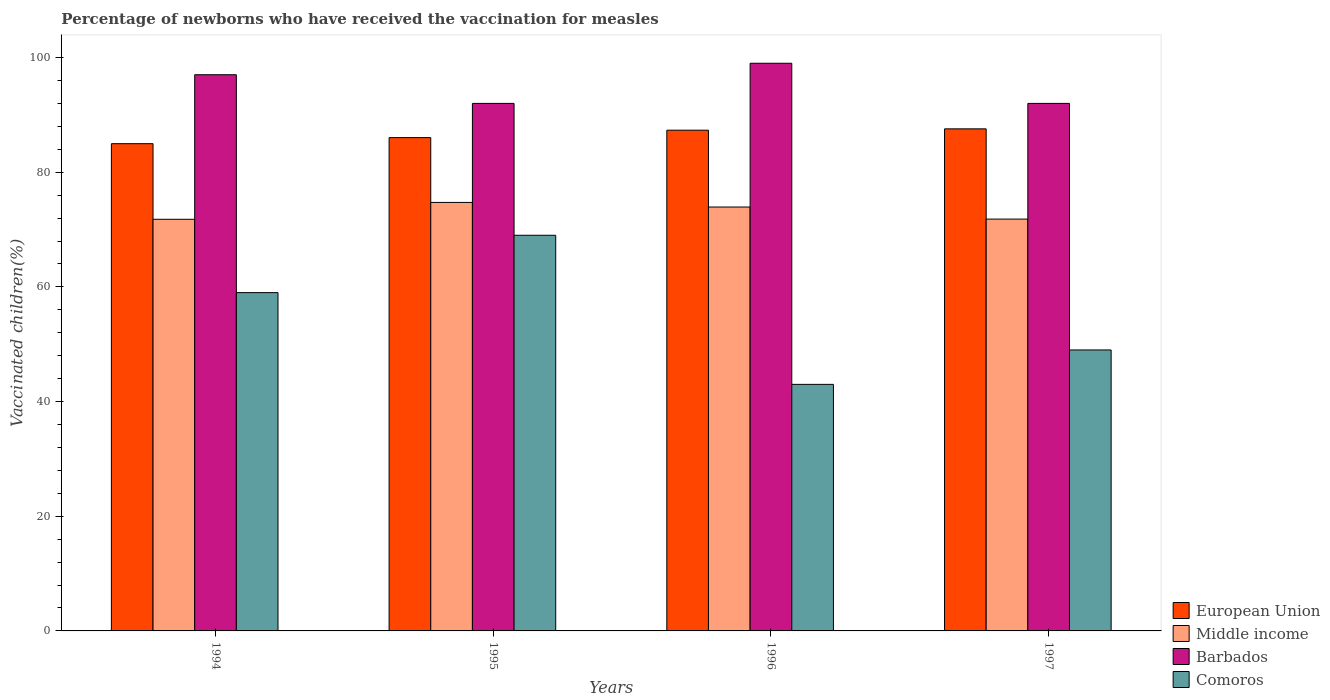How many different coloured bars are there?
Make the answer very short. 4. How many bars are there on the 1st tick from the right?
Ensure brevity in your answer.  4. What is the label of the 1st group of bars from the left?
Provide a short and direct response. 1994. In how many cases, is the number of bars for a given year not equal to the number of legend labels?
Keep it short and to the point. 0. What is the percentage of vaccinated children in Comoros in 1996?
Provide a succinct answer. 43. Across all years, what is the maximum percentage of vaccinated children in European Union?
Your answer should be very brief. 87.56. Across all years, what is the minimum percentage of vaccinated children in European Union?
Offer a terse response. 84.98. In which year was the percentage of vaccinated children in Barbados maximum?
Your answer should be compact. 1996. In which year was the percentage of vaccinated children in Barbados minimum?
Your response must be concise. 1995. What is the total percentage of vaccinated children in Barbados in the graph?
Ensure brevity in your answer.  380. What is the difference between the percentage of vaccinated children in Middle income in 1994 and that in 1996?
Provide a succinct answer. -2.14. What is the difference between the percentage of vaccinated children in Comoros in 1997 and the percentage of vaccinated children in Middle income in 1995?
Provide a short and direct response. -25.73. In the year 1995, what is the difference between the percentage of vaccinated children in European Union and percentage of vaccinated children in Barbados?
Make the answer very short. -5.97. What is the ratio of the percentage of vaccinated children in Middle income in 1994 to that in 1996?
Keep it short and to the point. 0.97. Is the percentage of vaccinated children in Barbados in 1994 less than that in 1997?
Give a very brief answer. No. What is the difference between the highest and the lowest percentage of vaccinated children in European Union?
Offer a very short reply. 2.59. What does the 1st bar from the left in 1995 represents?
Make the answer very short. European Union. What does the 1st bar from the right in 1996 represents?
Your answer should be compact. Comoros. How many bars are there?
Offer a very short reply. 16. Are all the bars in the graph horizontal?
Make the answer very short. No. What is the difference between two consecutive major ticks on the Y-axis?
Your answer should be very brief. 20. Does the graph contain any zero values?
Keep it short and to the point. No. Does the graph contain grids?
Offer a very short reply. No. Where does the legend appear in the graph?
Offer a very short reply. Bottom right. How are the legend labels stacked?
Your answer should be compact. Vertical. What is the title of the graph?
Keep it short and to the point. Percentage of newborns who have received the vaccination for measles. What is the label or title of the X-axis?
Your answer should be very brief. Years. What is the label or title of the Y-axis?
Offer a terse response. Vaccinated children(%). What is the Vaccinated children(%) of European Union in 1994?
Your response must be concise. 84.98. What is the Vaccinated children(%) in Middle income in 1994?
Provide a short and direct response. 71.79. What is the Vaccinated children(%) in Barbados in 1994?
Give a very brief answer. 97. What is the Vaccinated children(%) of Comoros in 1994?
Offer a very short reply. 59. What is the Vaccinated children(%) of European Union in 1995?
Your answer should be compact. 86.03. What is the Vaccinated children(%) in Middle income in 1995?
Provide a short and direct response. 74.73. What is the Vaccinated children(%) in Barbados in 1995?
Your response must be concise. 92. What is the Vaccinated children(%) of Comoros in 1995?
Keep it short and to the point. 69. What is the Vaccinated children(%) in European Union in 1996?
Your answer should be very brief. 87.32. What is the Vaccinated children(%) in Middle income in 1996?
Keep it short and to the point. 73.93. What is the Vaccinated children(%) of Comoros in 1996?
Your answer should be very brief. 43. What is the Vaccinated children(%) of European Union in 1997?
Make the answer very short. 87.56. What is the Vaccinated children(%) in Middle income in 1997?
Offer a very short reply. 71.82. What is the Vaccinated children(%) in Barbados in 1997?
Ensure brevity in your answer.  92. What is the Vaccinated children(%) of Comoros in 1997?
Offer a terse response. 49. Across all years, what is the maximum Vaccinated children(%) of European Union?
Provide a succinct answer. 87.56. Across all years, what is the maximum Vaccinated children(%) in Middle income?
Provide a short and direct response. 74.73. Across all years, what is the maximum Vaccinated children(%) of Barbados?
Provide a succinct answer. 99. Across all years, what is the minimum Vaccinated children(%) of European Union?
Your answer should be compact. 84.98. Across all years, what is the minimum Vaccinated children(%) of Middle income?
Your answer should be compact. 71.79. Across all years, what is the minimum Vaccinated children(%) of Barbados?
Offer a very short reply. 92. Across all years, what is the minimum Vaccinated children(%) in Comoros?
Keep it short and to the point. 43. What is the total Vaccinated children(%) of European Union in the graph?
Offer a terse response. 345.89. What is the total Vaccinated children(%) in Middle income in the graph?
Your response must be concise. 292.27. What is the total Vaccinated children(%) in Barbados in the graph?
Provide a succinct answer. 380. What is the total Vaccinated children(%) in Comoros in the graph?
Offer a terse response. 220. What is the difference between the Vaccinated children(%) of European Union in 1994 and that in 1995?
Ensure brevity in your answer.  -1.06. What is the difference between the Vaccinated children(%) of Middle income in 1994 and that in 1995?
Offer a very short reply. -2.94. What is the difference between the Vaccinated children(%) of Barbados in 1994 and that in 1995?
Offer a very short reply. 5. What is the difference between the Vaccinated children(%) in Comoros in 1994 and that in 1995?
Give a very brief answer. -10. What is the difference between the Vaccinated children(%) in European Union in 1994 and that in 1996?
Keep it short and to the point. -2.35. What is the difference between the Vaccinated children(%) in Middle income in 1994 and that in 1996?
Keep it short and to the point. -2.14. What is the difference between the Vaccinated children(%) in European Union in 1994 and that in 1997?
Your answer should be compact. -2.59. What is the difference between the Vaccinated children(%) of Middle income in 1994 and that in 1997?
Ensure brevity in your answer.  -0.03. What is the difference between the Vaccinated children(%) in Barbados in 1994 and that in 1997?
Your answer should be very brief. 5. What is the difference between the Vaccinated children(%) in Comoros in 1994 and that in 1997?
Offer a terse response. 10. What is the difference between the Vaccinated children(%) in European Union in 1995 and that in 1996?
Offer a very short reply. -1.29. What is the difference between the Vaccinated children(%) of Middle income in 1995 and that in 1996?
Provide a short and direct response. 0.8. What is the difference between the Vaccinated children(%) of Barbados in 1995 and that in 1996?
Make the answer very short. -7. What is the difference between the Vaccinated children(%) in Comoros in 1995 and that in 1996?
Ensure brevity in your answer.  26. What is the difference between the Vaccinated children(%) of European Union in 1995 and that in 1997?
Provide a short and direct response. -1.53. What is the difference between the Vaccinated children(%) of Middle income in 1995 and that in 1997?
Your answer should be compact. 2.91. What is the difference between the Vaccinated children(%) of Comoros in 1995 and that in 1997?
Give a very brief answer. 20. What is the difference between the Vaccinated children(%) of European Union in 1996 and that in 1997?
Your answer should be very brief. -0.24. What is the difference between the Vaccinated children(%) in Middle income in 1996 and that in 1997?
Ensure brevity in your answer.  2.11. What is the difference between the Vaccinated children(%) of European Union in 1994 and the Vaccinated children(%) of Middle income in 1995?
Ensure brevity in your answer.  10.25. What is the difference between the Vaccinated children(%) of European Union in 1994 and the Vaccinated children(%) of Barbados in 1995?
Provide a succinct answer. -7.02. What is the difference between the Vaccinated children(%) of European Union in 1994 and the Vaccinated children(%) of Comoros in 1995?
Your answer should be very brief. 15.98. What is the difference between the Vaccinated children(%) in Middle income in 1994 and the Vaccinated children(%) in Barbados in 1995?
Keep it short and to the point. -20.21. What is the difference between the Vaccinated children(%) in Middle income in 1994 and the Vaccinated children(%) in Comoros in 1995?
Make the answer very short. 2.79. What is the difference between the Vaccinated children(%) of European Union in 1994 and the Vaccinated children(%) of Middle income in 1996?
Provide a short and direct response. 11.05. What is the difference between the Vaccinated children(%) in European Union in 1994 and the Vaccinated children(%) in Barbados in 1996?
Give a very brief answer. -14.02. What is the difference between the Vaccinated children(%) in European Union in 1994 and the Vaccinated children(%) in Comoros in 1996?
Make the answer very short. 41.98. What is the difference between the Vaccinated children(%) of Middle income in 1994 and the Vaccinated children(%) of Barbados in 1996?
Provide a short and direct response. -27.21. What is the difference between the Vaccinated children(%) in Middle income in 1994 and the Vaccinated children(%) in Comoros in 1996?
Keep it short and to the point. 28.79. What is the difference between the Vaccinated children(%) in European Union in 1994 and the Vaccinated children(%) in Middle income in 1997?
Provide a short and direct response. 13.15. What is the difference between the Vaccinated children(%) of European Union in 1994 and the Vaccinated children(%) of Barbados in 1997?
Your response must be concise. -7.02. What is the difference between the Vaccinated children(%) of European Union in 1994 and the Vaccinated children(%) of Comoros in 1997?
Your response must be concise. 35.98. What is the difference between the Vaccinated children(%) in Middle income in 1994 and the Vaccinated children(%) in Barbados in 1997?
Offer a terse response. -20.21. What is the difference between the Vaccinated children(%) of Middle income in 1994 and the Vaccinated children(%) of Comoros in 1997?
Your answer should be compact. 22.79. What is the difference between the Vaccinated children(%) of European Union in 1995 and the Vaccinated children(%) of Middle income in 1996?
Provide a short and direct response. 12.1. What is the difference between the Vaccinated children(%) in European Union in 1995 and the Vaccinated children(%) in Barbados in 1996?
Make the answer very short. -12.97. What is the difference between the Vaccinated children(%) in European Union in 1995 and the Vaccinated children(%) in Comoros in 1996?
Keep it short and to the point. 43.03. What is the difference between the Vaccinated children(%) of Middle income in 1995 and the Vaccinated children(%) of Barbados in 1996?
Give a very brief answer. -24.27. What is the difference between the Vaccinated children(%) of Middle income in 1995 and the Vaccinated children(%) of Comoros in 1996?
Your response must be concise. 31.73. What is the difference between the Vaccinated children(%) in European Union in 1995 and the Vaccinated children(%) in Middle income in 1997?
Keep it short and to the point. 14.21. What is the difference between the Vaccinated children(%) in European Union in 1995 and the Vaccinated children(%) in Barbados in 1997?
Ensure brevity in your answer.  -5.97. What is the difference between the Vaccinated children(%) in European Union in 1995 and the Vaccinated children(%) in Comoros in 1997?
Provide a short and direct response. 37.03. What is the difference between the Vaccinated children(%) in Middle income in 1995 and the Vaccinated children(%) in Barbados in 1997?
Provide a succinct answer. -17.27. What is the difference between the Vaccinated children(%) in Middle income in 1995 and the Vaccinated children(%) in Comoros in 1997?
Keep it short and to the point. 25.73. What is the difference between the Vaccinated children(%) in Barbados in 1995 and the Vaccinated children(%) in Comoros in 1997?
Provide a succinct answer. 43. What is the difference between the Vaccinated children(%) of European Union in 1996 and the Vaccinated children(%) of Middle income in 1997?
Offer a very short reply. 15.5. What is the difference between the Vaccinated children(%) in European Union in 1996 and the Vaccinated children(%) in Barbados in 1997?
Your answer should be very brief. -4.68. What is the difference between the Vaccinated children(%) in European Union in 1996 and the Vaccinated children(%) in Comoros in 1997?
Give a very brief answer. 38.32. What is the difference between the Vaccinated children(%) of Middle income in 1996 and the Vaccinated children(%) of Barbados in 1997?
Keep it short and to the point. -18.07. What is the difference between the Vaccinated children(%) in Middle income in 1996 and the Vaccinated children(%) in Comoros in 1997?
Keep it short and to the point. 24.93. What is the average Vaccinated children(%) in European Union per year?
Your answer should be compact. 86.47. What is the average Vaccinated children(%) in Middle income per year?
Offer a terse response. 73.07. What is the average Vaccinated children(%) in Barbados per year?
Keep it short and to the point. 95. In the year 1994, what is the difference between the Vaccinated children(%) of European Union and Vaccinated children(%) of Middle income?
Provide a short and direct response. 13.19. In the year 1994, what is the difference between the Vaccinated children(%) of European Union and Vaccinated children(%) of Barbados?
Make the answer very short. -12.02. In the year 1994, what is the difference between the Vaccinated children(%) of European Union and Vaccinated children(%) of Comoros?
Provide a succinct answer. 25.98. In the year 1994, what is the difference between the Vaccinated children(%) of Middle income and Vaccinated children(%) of Barbados?
Your answer should be compact. -25.21. In the year 1994, what is the difference between the Vaccinated children(%) in Middle income and Vaccinated children(%) in Comoros?
Provide a succinct answer. 12.79. In the year 1994, what is the difference between the Vaccinated children(%) of Barbados and Vaccinated children(%) of Comoros?
Ensure brevity in your answer.  38. In the year 1995, what is the difference between the Vaccinated children(%) of European Union and Vaccinated children(%) of Middle income?
Provide a short and direct response. 11.3. In the year 1995, what is the difference between the Vaccinated children(%) of European Union and Vaccinated children(%) of Barbados?
Provide a succinct answer. -5.97. In the year 1995, what is the difference between the Vaccinated children(%) in European Union and Vaccinated children(%) in Comoros?
Your answer should be very brief. 17.03. In the year 1995, what is the difference between the Vaccinated children(%) in Middle income and Vaccinated children(%) in Barbados?
Give a very brief answer. -17.27. In the year 1995, what is the difference between the Vaccinated children(%) of Middle income and Vaccinated children(%) of Comoros?
Keep it short and to the point. 5.73. In the year 1996, what is the difference between the Vaccinated children(%) of European Union and Vaccinated children(%) of Middle income?
Your answer should be compact. 13.4. In the year 1996, what is the difference between the Vaccinated children(%) of European Union and Vaccinated children(%) of Barbados?
Give a very brief answer. -11.68. In the year 1996, what is the difference between the Vaccinated children(%) of European Union and Vaccinated children(%) of Comoros?
Your answer should be compact. 44.32. In the year 1996, what is the difference between the Vaccinated children(%) in Middle income and Vaccinated children(%) in Barbados?
Give a very brief answer. -25.07. In the year 1996, what is the difference between the Vaccinated children(%) in Middle income and Vaccinated children(%) in Comoros?
Offer a terse response. 30.93. In the year 1997, what is the difference between the Vaccinated children(%) in European Union and Vaccinated children(%) in Middle income?
Keep it short and to the point. 15.74. In the year 1997, what is the difference between the Vaccinated children(%) in European Union and Vaccinated children(%) in Barbados?
Your answer should be compact. -4.44. In the year 1997, what is the difference between the Vaccinated children(%) of European Union and Vaccinated children(%) of Comoros?
Your answer should be compact. 38.56. In the year 1997, what is the difference between the Vaccinated children(%) in Middle income and Vaccinated children(%) in Barbados?
Your response must be concise. -20.18. In the year 1997, what is the difference between the Vaccinated children(%) of Middle income and Vaccinated children(%) of Comoros?
Provide a short and direct response. 22.82. In the year 1997, what is the difference between the Vaccinated children(%) of Barbados and Vaccinated children(%) of Comoros?
Your response must be concise. 43. What is the ratio of the Vaccinated children(%) of European Union in 1994 to that in 1995?
Offer a very short reply. 0.99. What is the ratio of the Vaccinated children(%) of Middle income in 1994 to that in 1995?
Your response must be concise. 0.96. What is the ratio of the Vaccinated children(%) of Barbados in 1994 to that in 1995?
Your answer should be very brief. 1.05. What is the ratio of the Vaccinated children(%) of Comoros in 1994 to that in 1995?
Make the answer very short. 0.86. What is the ratio of the Vaccinated children(%) in European Union in 1994 to that in 1996?
Your answer should be compact. 0.97. What is the ratio of the Vaccinated children(%) of Middle income in 1994 to that in 1996?
Provide a succinct answer. 0.97. What is the ratio of the Vaccinated children(%) in Barbados in 1994 to that in 1996?
Provide a succinct answer. 0.98. What is the ratio of the Vaccinated children(%) in Comoros in 1994 to that in 1996?
Your answer should be very brief. 1.37. What is the ratio of the Vaccinated children(%) in European Union in 1994 to that in 1997?
Provide a short and direct response. 0.97. What is the ratio of the Vaccinated children(%) of Barbados in 1994 to that in 1997?
Provide a short and direct response. 1.05. What is the ratio of the Vaccinated children(%) of Comoros in 1994 to that in 1997?
Give a very brief answer. 1.2. What is the ratio of the Vaccinated children(%) in European Union in 1995 to that in 1996?
Offer a terse response. 0.99. What is the ratio of the Vaccinated children(%) in Middle income in 1995 to that in 1996?
Provide a short and direct response. 1.01. What is the ratio of the Vaccinated children(%) in Barbados in 1995 to that in 1996?
Give a very brief answer. 0.93. What is the ratio of the Vaccinated children(%) of Comoros in 1995 to that in 1996?
Keep it short and to the point. 1.6. What is the ratio of the Vaccinated children(%) in European Union in 1995 to that in 1997?
Keep it short and to the point. 0.98. What is the ratio of the Vaccinated children(%) of Middle income in 1995 to that in 1997?
Offer a very short reply. 1.04. What is the ratio of the Vaccinated children(%) of Comoros in 1995 to that in 1997?
Make the answer very short. 1.41. What is the ratio of the Vaccinated children(%) in Middle income in 1996 to that in 1997?
Make the answer very short. 1.03. What is the ratio of the Vaccinated children(%) in Barbados in 1996 to that in 1997?
Make the answer very short. 1.08. What is the ratio of the Vaccinated children(%) in Comoros in 1996 to that in 1997?
Keep it short and to the point. 0.88. What is the difference between the highest and the second highest Vaccinated children(%) of European Union?
Ensure brevity in your answer.  0.24. What is the difference between the highest and the second highest Vaccinated children(%) in Middle income?
Your response must be concise. 0.8. What is the difference between the highest and the lowest Vaccinated children(%) in European Union?
Provide a succinct answer. 2.59. What is the difference between the highest and the lowest Vaccinated children(%) in Middle income?
Your answer should be compact. 2.94. What is the difference between the highest and the lowest Vaccinated children(%) in Barbados?
Your answer should be very brief. 7. 